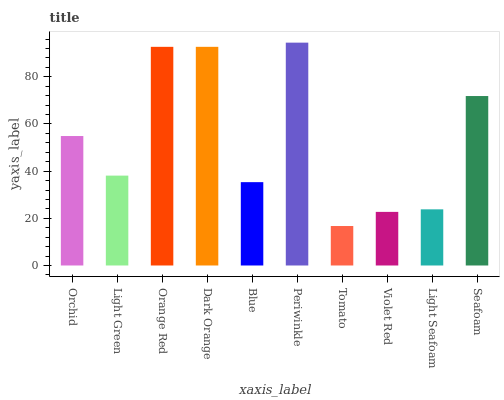Is Tomato the minimum?
Answer yes or no. Yes. Is Periwinkle the maximum?
Answer yes or no. Yes. Is Light Green the minimum?
Answer yes or no. No. Is Light Green the maximum?
Answer yes or no. No. Is Orchid greater than Light Green?
Answer yes or no. Yes. Is Light Green less than Orchid?
Answer yes or no. Yes. Is Light Green greater than Orchid?
Answer yes or no. No. Is Orchid less than Light Green?
Answer yes or no. No. Is Orchid the high median?
Answer yes or no. Yes. Is Light Green the low median?
Answer yes or no. Yes. Is Tomato the high median?
Answer yes or no. No. Is Light Seafoam the low median?
Answer yes or no. No. 